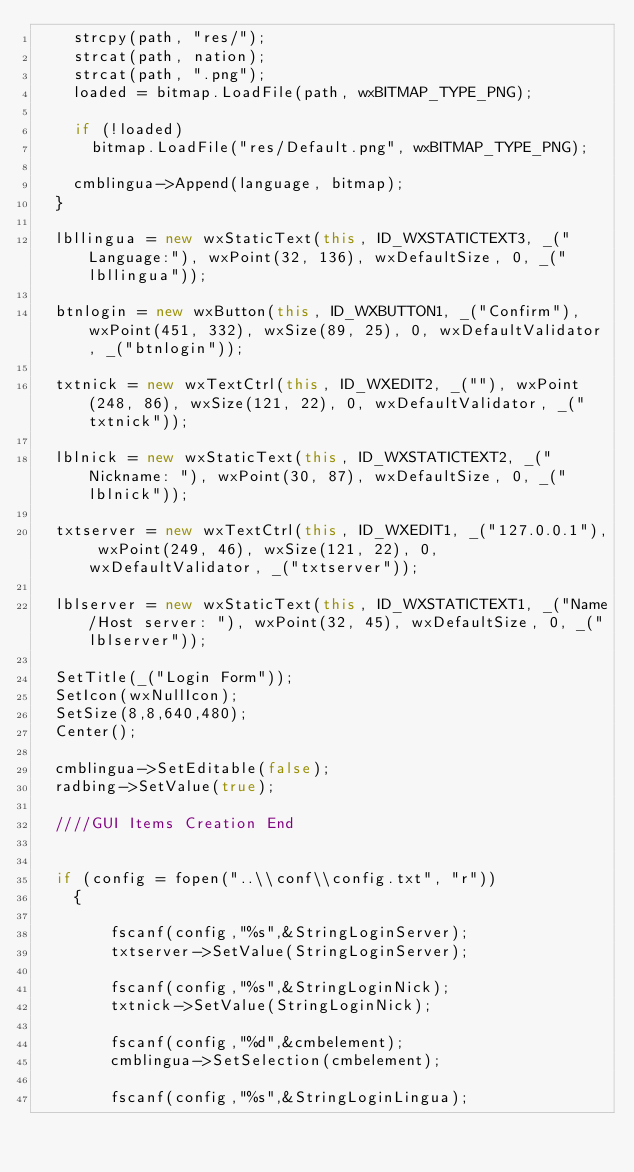<code> <loc_0><loc_0><loc_500><loc_500><_C++_>		strcpy(path, "res/");
		strcat(path, nation);
		strcat(path, ".png");
		loaded = bitmap.LoadFile(path, wxBITMAP_TYPE_PNG);

		if (!loaded)
			bitmap.LoadFile("res/Default.png", wxBITMAP_TYPE_PNG);

		cmblingua->Append(language, bitmap);
	}
	
	lbllingua = new wxStaticText(this, ID_WXSTATICTEXT3, _("Language:"), wxPoint(32, 136), wxDefaultSize, 0, _("lbllingua"));

	btnlogin = new wxButton(this, ID_WXBUTTON1, _("Confirm"), wxPoint(451, 332), wxSize(89, 25), 0, wxDefaultValidator, _("btnlogin"));

	txtnick = new wxTextCtrl(this, ID_WXEDIT2, _(""), wxPoint(248, 86), wxSize(121, 22), 0, wxDefaultValidator, _("txtnick"));

	lblnick = new wxStaticText(this, ID_WXSTATICTEXT2, _("Nickname: "), wxPoint(30, 87), wxDefaultSize, 0, _("lblnick"));

	txtserver = new wxTextCtrl(this, ID_WXEDIT1, _("127.0.0.1"), wxPoint(249, 46), wxSize(121, 22), 0, wxDefaultValidator, _("txtserver"));

	lblserver = new wxStaticText(this, ID_WXSTATICTEXT1, _("Name/Host server: "), wxPoint(32, 45), wxDefaultSize, 0, _("lblserver"));

	SetTitle(_("Login Form"));
	SetIcon(wxNullIcon);
	SetSize(8,8,640,480);
	Center();
	
	cmblingua->SetEditable(false);
	radbing->SetValue(true);

	////GUI Items Creation End
	
	
	if (config = fopen("..\\conf\\config.txt", "r"))
    {

        fscanf(config,"%s",&StringLoginServer);
        txtserver->SetValue(StringLoginServer);
        
        fscanf(config,"%s",&StringLoginNick);
        txtnick->SetValue(StringLoginNick);
        
        fscanf(config,"%d",&cmbelement);
        cmblingua->SetSelection(cmbelement);
        
        fscanf(config,"%s",&StringLoginLingua);</code> 